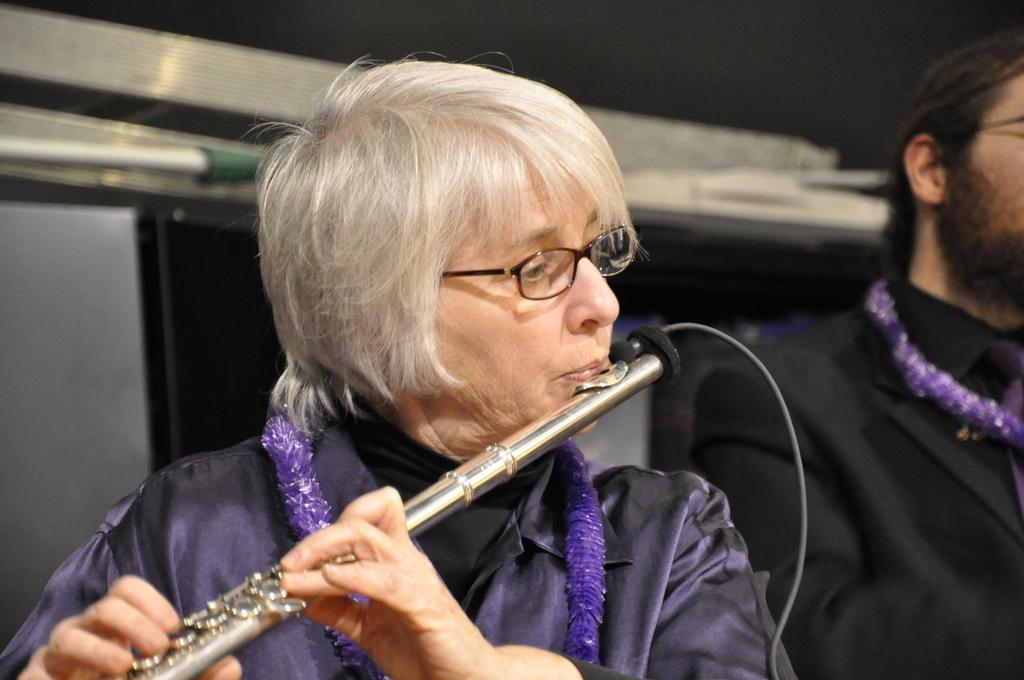What is the woman in the image doing? The woman is playing a flute in the image. How is the woman holding the flute? The woman is holding the flute with both hands. Who else is present in the image? There is a man in the image. Where is the man positioned in relation to the woman? The man is standing on the woman's left side. What type of texture can be seen on the flute in the image? There is no information about the texture of the flute in the image, and the flute itself is not mentioned as having a specific texture. 